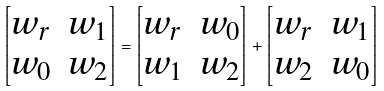<formula> <loc_0><loc_0><loc_500><loc_500>\begin{bmatrix} w _ { r } & w _ { 1 } \\ w _ { 0 } & w _ { 2 } \end{bmatrix} = \begin{bmatrix} w _ { r } & w _ { 0 } \\ w _ { 1 } & w _ { 2 } \end{bmatrix} + \begin{bmatrix} w _ { r } & w _ { 1 } \\ w _ { 2 } & w _ { 0 } \end{bmatrix}</formula> 